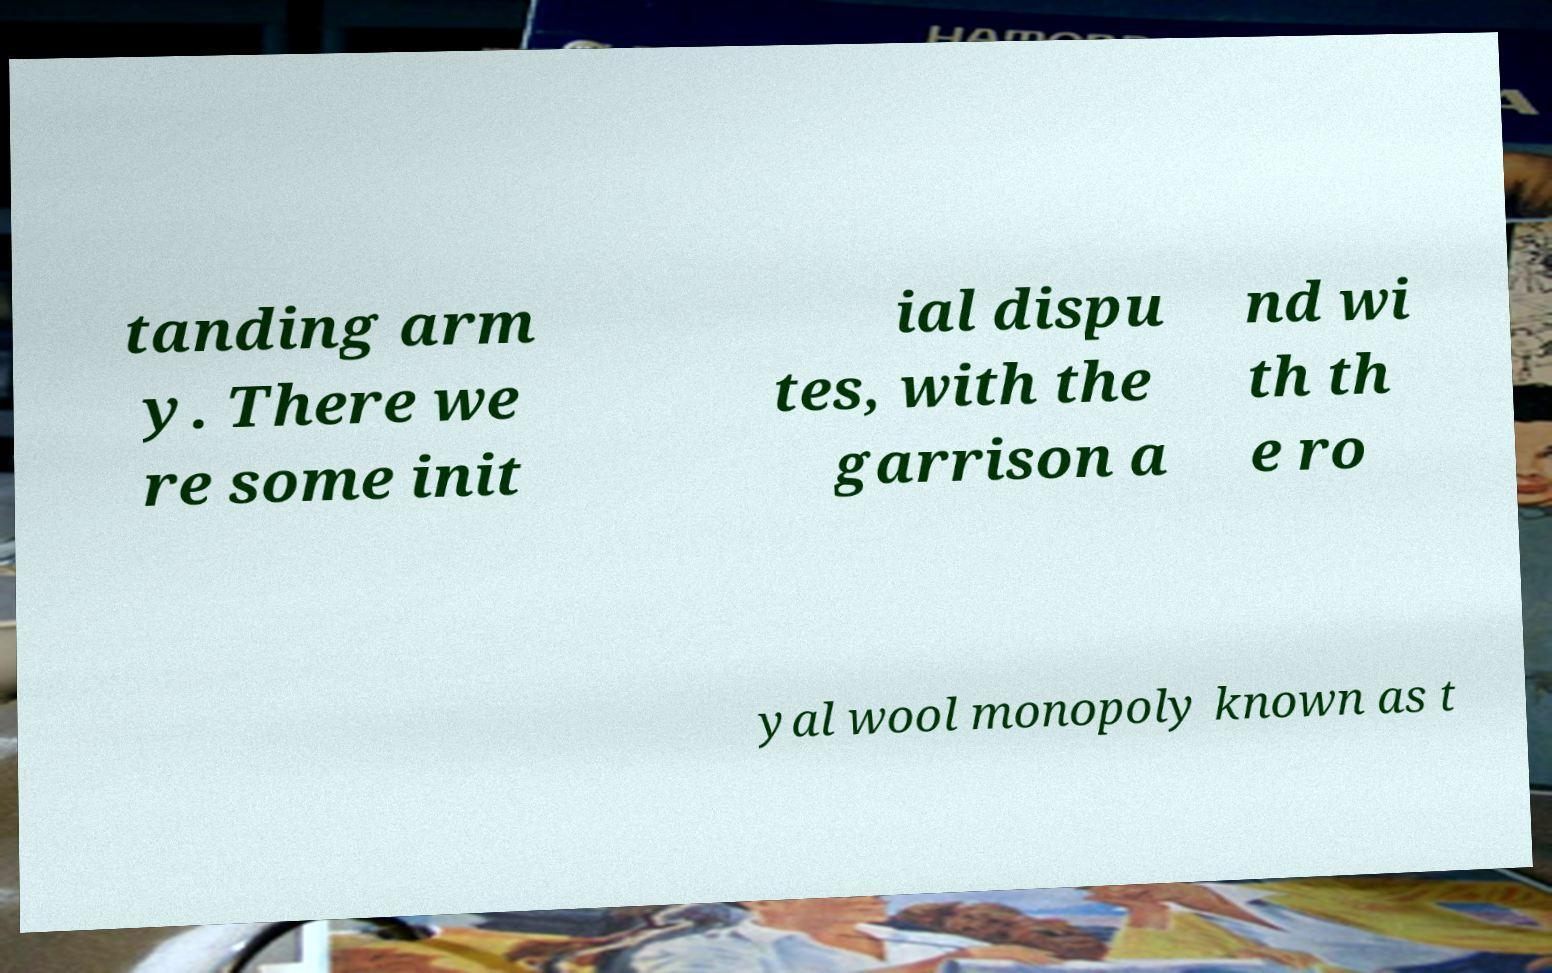Could you assist in decoding the text presented in this image and type it out clearly? tanding arm y. There we re some init ial dispu tes, with the garrison a nd wi th th e ro yal wool monopoly known as t 